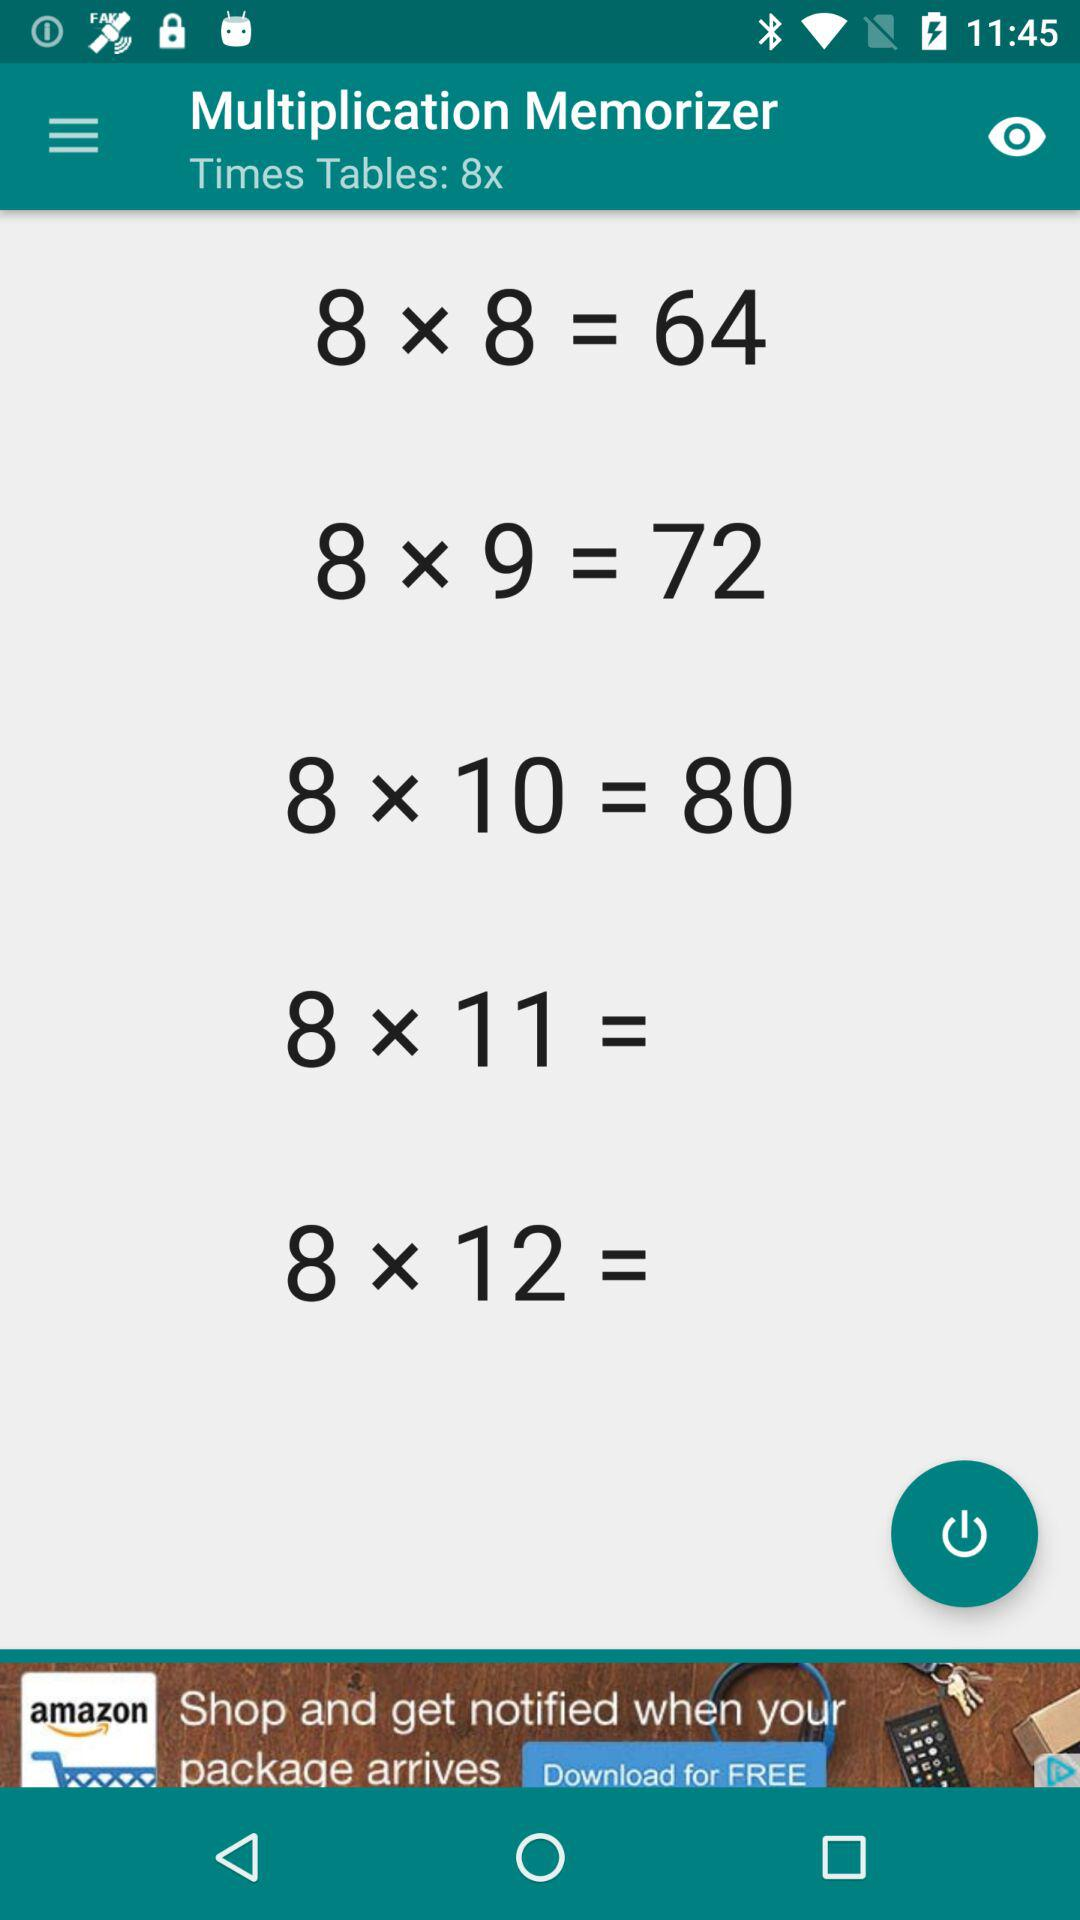60 is the output of which multiplication?
When the provided information is insufficient, respond with <no answer>. <no answer> 